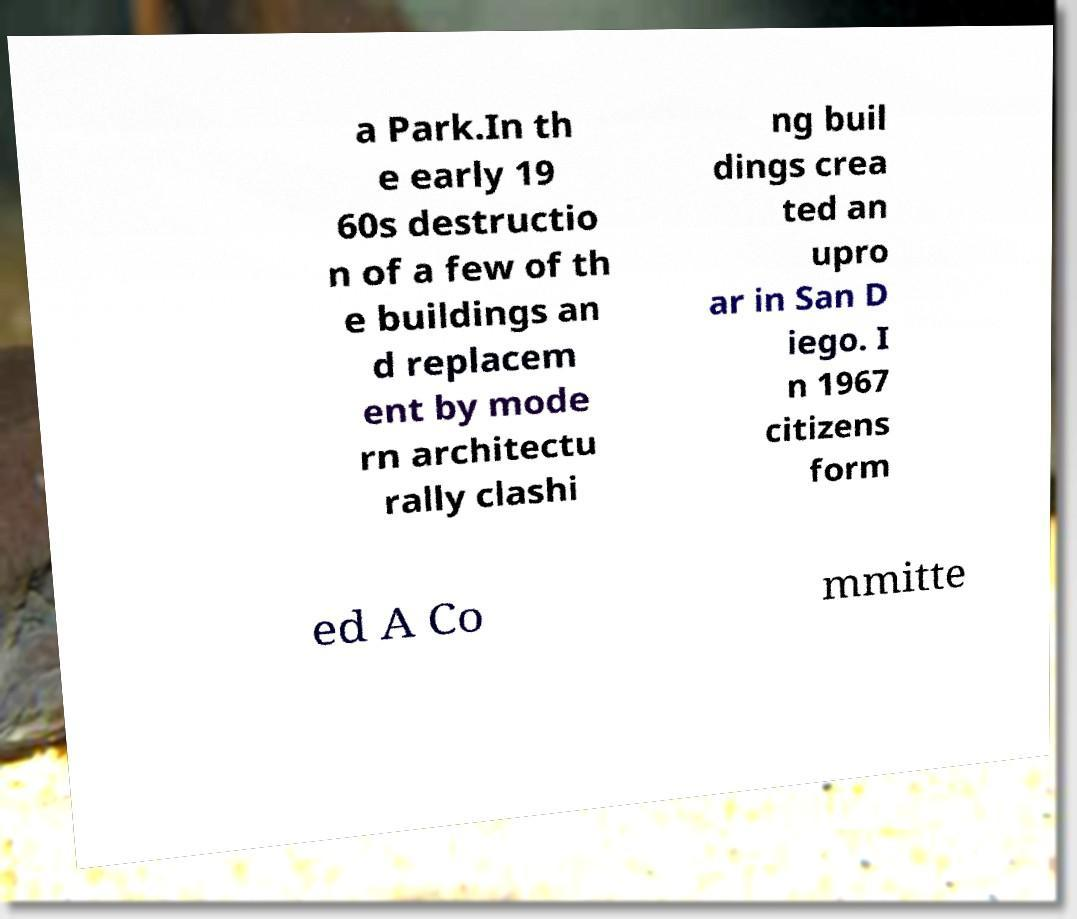I need the written content from this picture converted into text. Can you do that? a Park.In th e early 19 60s destructio n of a few of th e buildings an d replacem ent by mode rn architectu rally clashi ng buil dings crea ted an upro ar in San D iego. I n 1967 citizens form ed A Co mmitte 